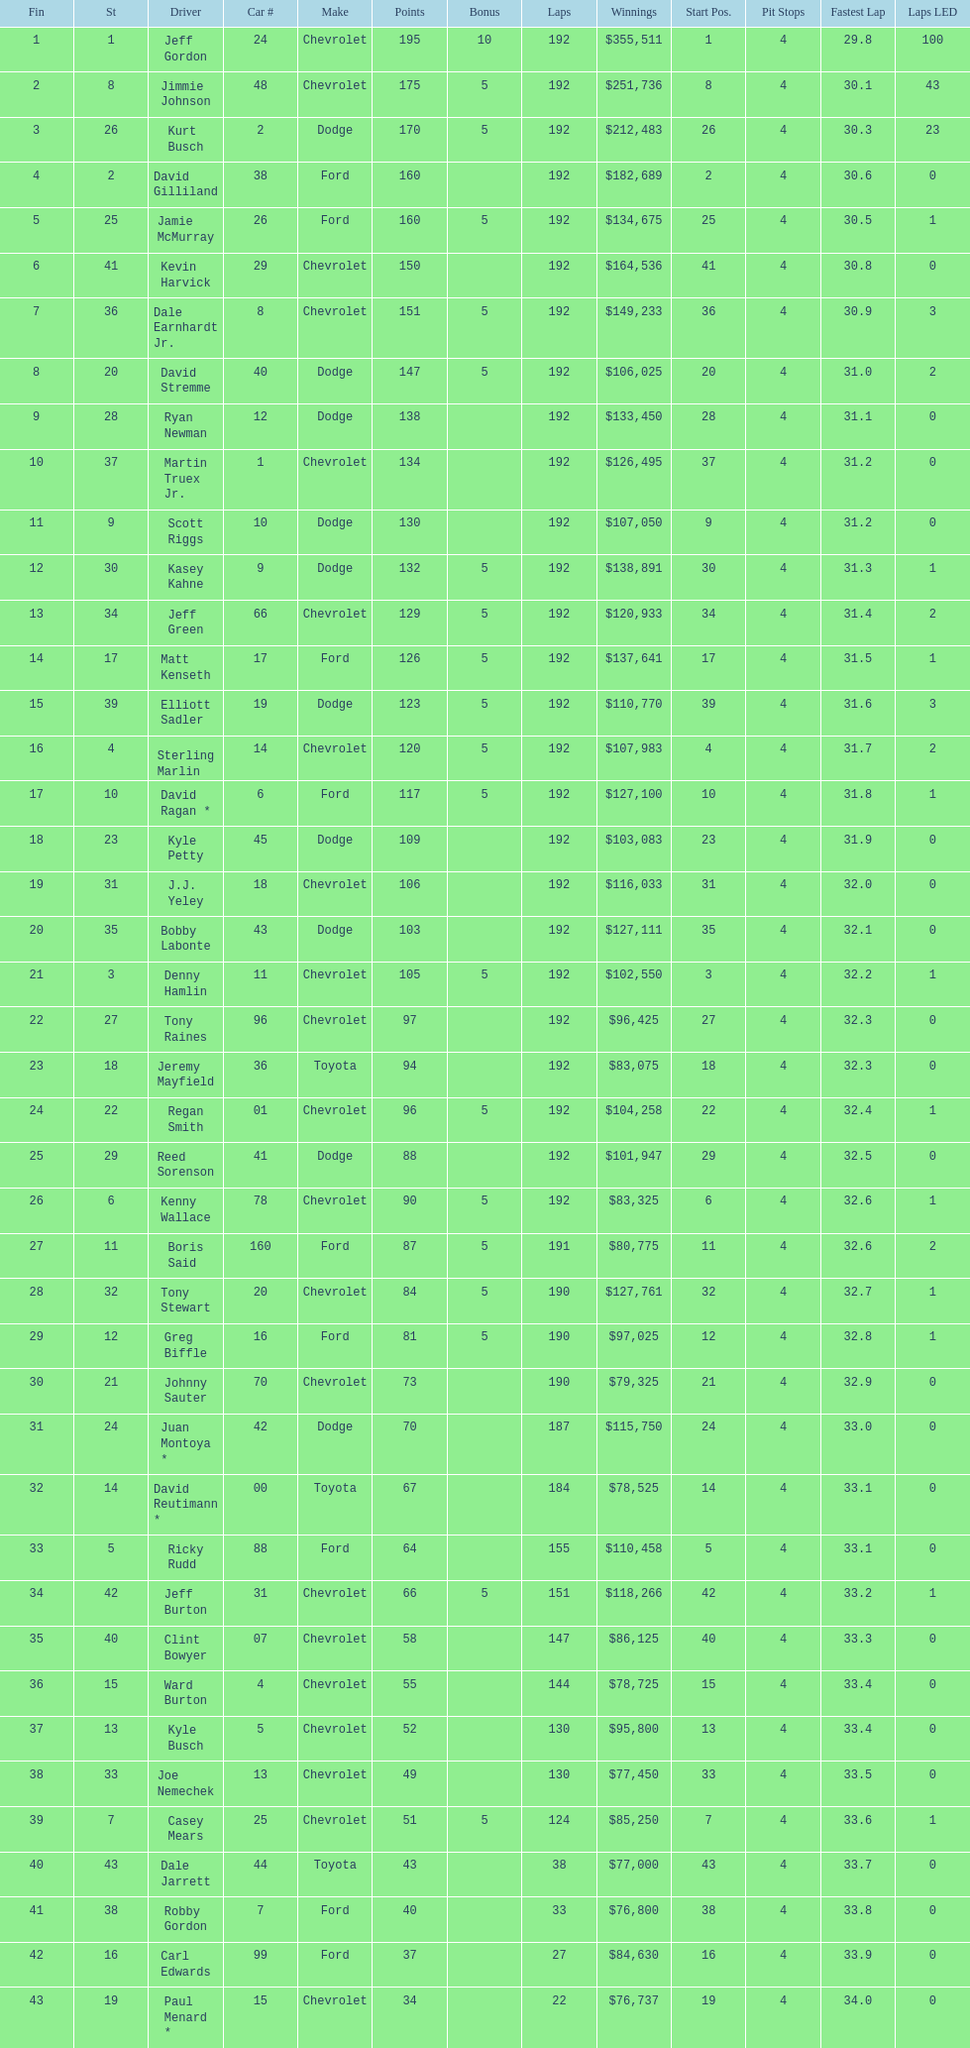How many drivers earned no bonus for this race? 23. Write the full table. {'header': ['Fin', 'St', 'Driver', 'Car #', 'Make', 'Points', 'Bonus', 'Laps', 'Winnings', 'Start Pos.', 'Pit Stops', 'Fastest Lap', 'Laps LED'], 'rows': [['1', '1', 'Jeff Gordon', '24', 'Chevrolet', '195', '10', '192', '$355,511', '1', '4', '29.8', '100'], ['2', '8', 'Jimmie Johnson', '48', 'Chevrolet', '175', '5', '192', '$251,736', '8', '4', '30.1', '43'], ['3', '26', 'Kurt Busch', '2', 'Dodge', '170', '5', '192', '$212,483', '26', '4', '30.3', '23'], ['4', '2', 'David Gilliland', '38', 'Ford', '160', '', '192', '$182,689', '2', '4', '30.6', '0'], ['5', '25', 'Jamie McMurray', '26', 'Ford', '160', '5', '192', '$134,675', '25', '4', '30.5', '1'], ['6', '41', 'Kevin Harvick', '29', 'Chevrolet', '150', '', '192', '$164,536', '41', '4', '30.8', '0'], ['7', '36', 'Dale Earnhardt Jr.', '8', 'Chevrolet', '151', '5', '192', '$149,233', '36', '4', '30.9', '3'], ['8', '20', 'David Stremme', '40', 'Dodge', '147', '5', '192', '$106,025', '20', '4', '31.0', '2'], ['9', '28', 'Ryan Newman', '12', 'Dodge', '138', '', '192', '$133,450', '28', '4', '31.1', '0'], ['10', '37', 'Martin Truex Jr.', '1', 'Chevrolet', '134', '', '192', '$126,495', '37', '4', '31.2', '0'], ['11', '9', 'Scott Riggs', '10', 'Dodge', '130', '', '192', '$107,050', '9', '4', '31.2', '0'], ['12', '30', 'Kasey Kahne', '9', 'Dodge', '132', '5', '192', '$138,891', '30', '4', '31.3', '1'], ['13', '34', 'Jeff Green', '66', 'Chevrolet', '129', '5', '192', '$120,933', '34', '4', '31.4', '2'], ['14', '17', 'Matt Kenseth', '17', 'Ford', '126', '5', '192', '$137,641', '17', '4', '31.5', '1'], ['15', '39', 'Elliott Sadler', '19', 'Dodge', '123', '5', '192', '$110,770', '39', '4', '31.6', '3'], ['16', '4', 'Sterling Marlin', '14', 'Chevrolet', '120', '5', '192', '$107,983', '4', '4', '31.7', '2'], ['17', '10', 'David Ragan *', '6', 'Ford', '117', '5', '192', '$127,100', '10', '4', '31.8', '1'], ['18', '23', 'Kyle Petty', '45', 'Dodge', '109', '', '192', '$103,083', '23', '4', '31.9', '0'], ['19', '31', 'J.J. Yeley', '18', 'Chevrolet', '106', '', '192', '$116,033', '31', '4', '32.0', '0'], ['20', '35', 'Bobby Labonte', '43', 'Dodge', '103', '', '192', '$127,111', '35', '4', '32.1', '0'], ['21', '3', 'Denny Hamlin', '11', 'Chevrolet', '105', '5', '192', '$102,550', '3', '4', '32.2', '1'], ['22', '27', 'Tony Raines', '96', 'Chevrolet', '97', '', '192', '$96,425', '27', '4', '32.3', '0'], ['23', '18', 'Jeremy Mayfield', '36', 'Toyota', '94', '', '192', '$83,075', '18', '4', '32.3', '0'], ['24', '22', 'Regan Smith', '01', 'Chevrolet', '96', '5', '192', '$104,258', '22', '4', '32.4', '1'], ['25', '29', 'Reed Sorenson', '41', 'Dodge', '88', '', '192', '$101,947', '29', '4', '32.5', '0'], ['26', '6', 'Kenny Wallace', '78', 'Chevrolet', '90', '5', '192', '$83,325', '6', '4', '32.6', '1'], ['27', '11', 'Boris Said', '160', 'Ford', '87', '5', '191', '$80,775', '11', '4', '32.6', '2'], ['28', '32', 'Tony Stewart', '20', 'Chevrolet', '84', '5', '190', '$127,761', '32', '4', '32.7', '1'], ['29', '12', 'Greg Biffle', '16', 'Ford', '81', '5', '190', '$97,025', '12', '4', '32.8', '1'], ['30', '21', 'Johnny Sauter', '70', 'Chevrolet', '73', '', '190', '$79,325', '21', '4', '32.9', '0'], ['31', '24', 'Juan Montoya *', '42', 'Dodge', '70', '', '187', '$115,750', '24', '4', '33.0', '0'], ['32', '14', 'David Reutimann *', '00', 'Toyota', '67', '', '184', '$78,525', '14', '4', '33.1', '0'], ['33', '5', 'Ricky Rudd', '88', 'Ford', '64', '', '155', '$110,458', '5', '4', '33.1', '0'], ['34', '42', 'Jeff Burton', '31', 'Chevrolet', '66', '5', '151', '$118,266', '42', '4', '33.2', '1'], ['35', '40', 'Clint Bowyer', '07', 'Chevrolet', '58', '', '147', '$86,125', '40', '4', '33.3', '0'], ['36', '15', 'Ward Burton', '4', 'Chevrolet', '55', '', '144', '$78,725', '15', '4', '33.4', '0'], ['37', '13', 'Kyle Busch', '5', 'Chevrolet', '52', '', '130', '$95,800', '13', '4', '33.4', '0'], ['38', '33', 'Joe Nemechek', '13', 'Chevrolet', '49', '', '130', '$77,450', '33', '4', '33.5', '0'], ['39', '7', 'Casey Mears', '25', 'Chevrolet', '51', '5', '124', '$85,250', '7', '4', '33.6', '1'], ['40', '43', 'Dale Jarrett', '44', 'Toyota', '43', '', '38', '$77,000', '43', '4', '33.7', '0'], ['41', '38', 'Robby Gordon', '7', 'Ford', '40', '', '33', '$76,800', '38', '4', '33.8', '0'], ['42', '16', 'Carl Edwards', '99', 'Ford', '37', '', '27', '$84,630', '16', '4', '33.9', '0'], ['43', '19', 'Paul Menard *', '15', 'Chevrolet', '34', '', '22', '$76,737', '19', '4', '34.0', '0']]} 